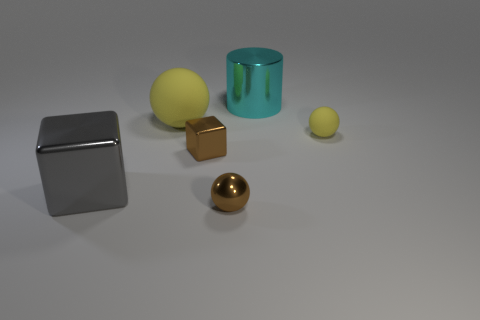Add 3 large brown blocks. How many objects exist? 9 Subtract all cylinders. How many objects are left? 5 Subtract all tiny spheres. Subtract all large yellow spheres. How many objects are left? 3 Add 3 cylinders. How many cylinders are left? 4 Add 4 green cubes. How many green cubes exist? 4 Subtract 0 blue blocks. How many objects are left? 6 